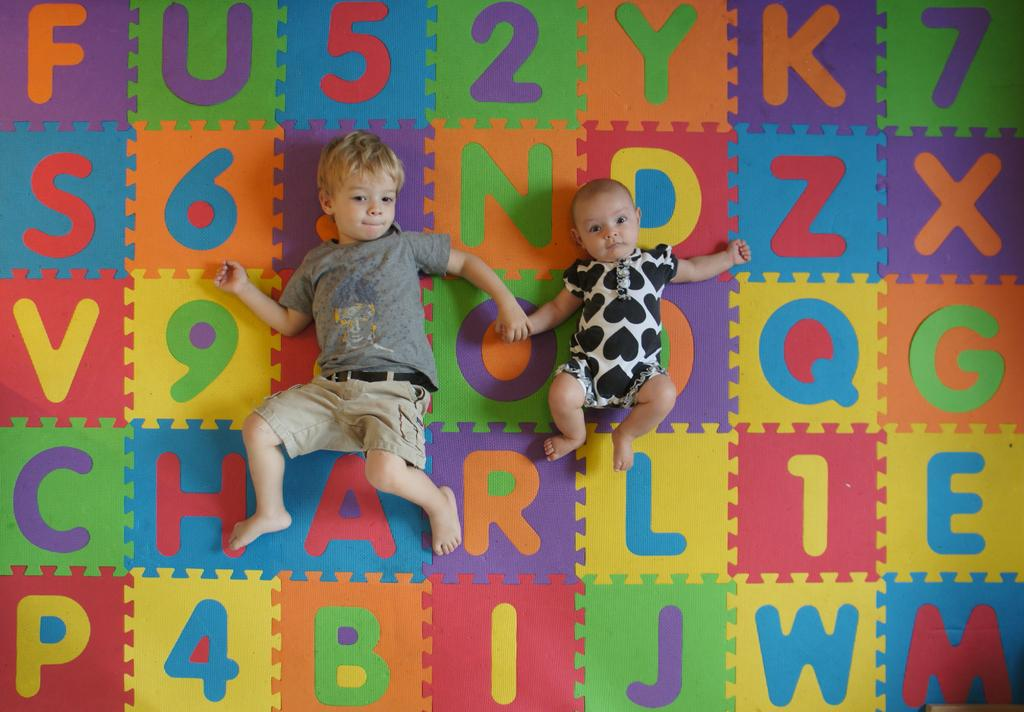How many kids are in the image? There are two kids in the image. What are the kids doing in the image? The kids are laying on a colorful surface. What can be seen on the surface where the kids are laying? The surface has letters on it. What type of porter is carrying a bag of salt in the image? There is no porter or bag of salt present in the image. Can you describe the squirrel that is playing with the letters on the surface? There is no squirrel present in the image; the image only features two kids laying on a colorful surface with letters on it. 